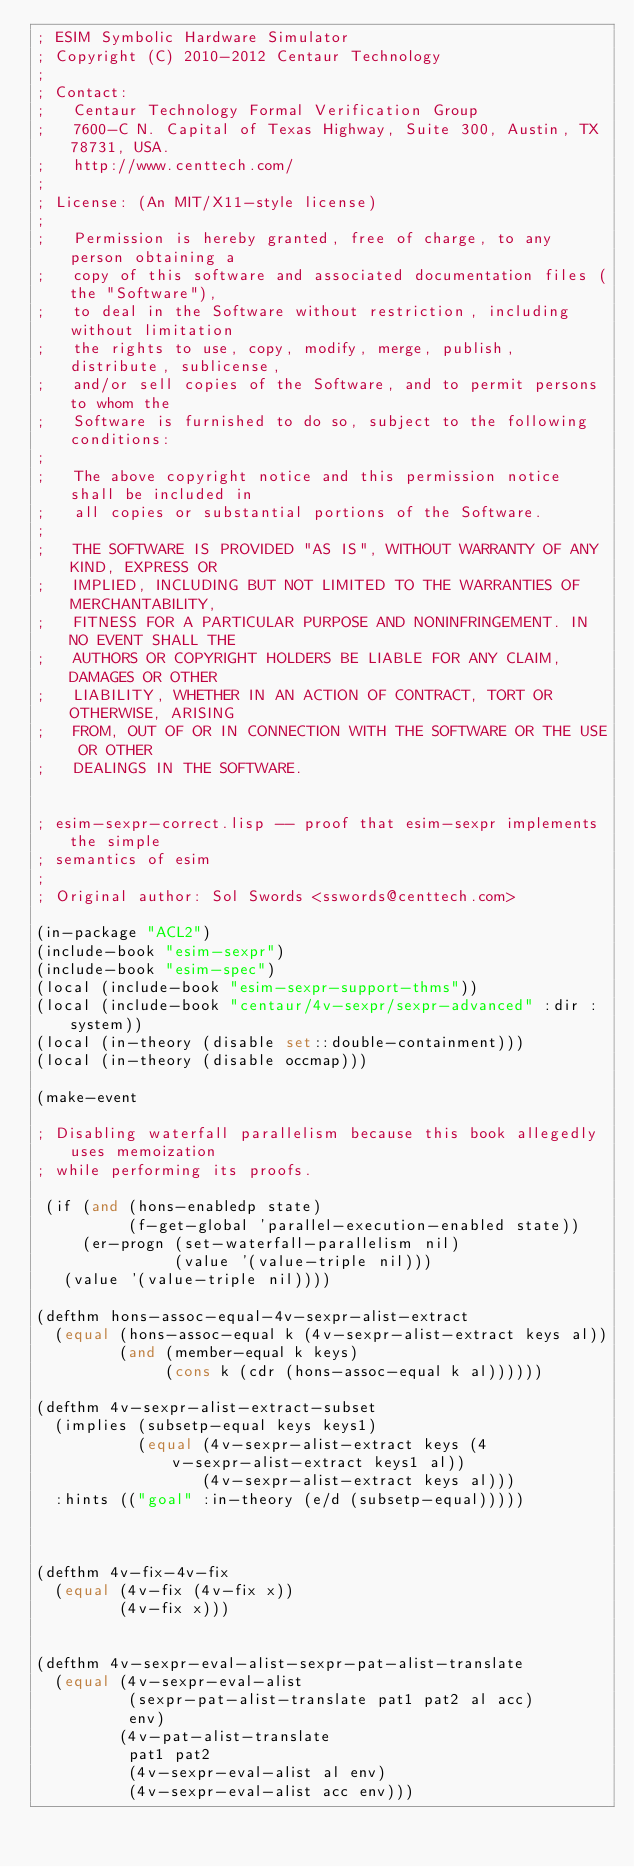Convert code to text. <code><loc_0><loc_0><loc_500><loc_500><_Lisp_>; ESIM Symbolic Hardware Simulator
; Copyright (C) 2010-2012 Centaur Technology
;
; Contact:
;   Centaur Technology Formal Verification Group
;   7600-C N. Capital of Texas Highway, Suite 300, Austin, TX 78731, USA.
;   http://www.centtech.com/
;
; License: (An MIT/X11-style license)
;
;   Permission is hereby granted, free of charge, to any person obtaining a
;   copy of this software and associated documentation files (the "Software"),
;   to deal in the Software without restriction, including without limitation
;   the rights to use, copy, modify, merge, publish, distribute, sublicense,
;   and/or sell copies of the Software, and to permit persons to whom the
;   Software is furnished to do so, subject to the following conditions:
;
;   The above copyright notice and this permission notice shall be included in
;   all copies or substantial portions of the Software.
;
;   THE SOFTWARE IS PROVIDED "AS IS", WITHOUT WARRANTY OF ANY KIND, EXPRESS OR
;   IMPLIED, INCLUDING BUT NOT LIMITED TO THE WARRANTIES OF MERCHANTABILITY,
;   FITNESS FOR A PARTICULAR PURPOSE AND NONINFRINGEMENT. IN NO EVENT SHALL THE
;   AUTHORS OR COPYRIGHT HOLDERS BE LIABLE FOR ANY CLAIM, DAMAGES OR OTHER
;   LIABILITY, WHETHER IN AN ACTION OF CONTRACT, TORT OR OTHERWISE, ARISING
;   FROM, OUT OF OR IN CONNECTION WITH THE SOFTWARE OR THE USE OR OTHER
;   DEALINGS IN THE SOFTWARE.


; esim-sexpr-correct.lisp -- proof that esim-sexpr implements the simple
; semantics of esim
;
; Original author: Sol Swords <sswords@centtech.com>

(in-package "ACL2")
(include-book "esim-sexpr")
(include-book "esim-spec")
(local (include-book "esim-sexpr-support-thms"))
(local (include-book "centaur/4v-sexpr/sexpr-advanced" :dir :system))
(local (in-theory (disable set::double-containment)))
(local (in-theory (disable occmap)))

(make-event

; Disabling waterfall parallelism because this book allegedly uses memoization
; while performing its proofs.

 (if (and (hons-enabledp state)
          (f-get-global 'parallel-execution-enabled state))
     (er-progn (set-waterfall-parallelism nil)
               (value '(value-triple nil)))
   (value '(value-triple nil))))

(defthm hons-assoc-equal-4v-sexpr-alist-extract
  (equal (hons-assoc-equal k (4v-sexpr-alist-extract keys al))
         (and (member-equal k keys)
              (cons k (cdr (hons-assoc-equal k al))))))

(defthm 4v-sexpr-alist-extract-subset
  (implies (subsetp-equal keys keys1)
           (equal (4v-sexpr-alist-extract keys (4v-sexpr-alist-extract keys1 al))
                  (4v-sexpr-alist-extract keys al)))
  :hints (("goal" :in-theory (e/d (subsetp-equal)))))



(defthm 4v-fix-4v-fix
  (equal (4v-fix (4v-fix x))
         (4v-fix x)))


(defthm 4v-sexpr-eval-alist-sexpr-pat-alist-translate
  (equal (4v-sexpr-eval-alist
          (sexpr-pat-alist-translate pat1 pat2 al acc)
          env)
         (4v-pat-alist-translate
          pat1 pat2
          (4v-sexpr-eval-alist al env)
          (4v-sexpr-eval-alist acc env)))</code> 